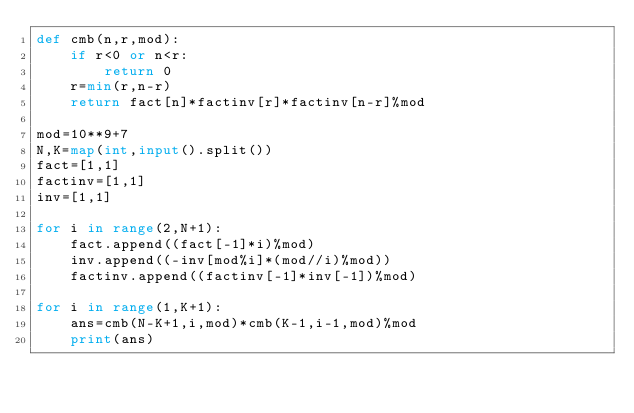Convert code to text. <code><loc_0><loc_0><loc_500><loc_500><_Python_>def cmb(n,r,mod):
    if r<0 or n<r:
        return 0
    r=min(r,n-r)
    return fact[n]*factinv[r]*factinv[n-r]%mod

mod=10**9+7
N,K=map(int,input().split())
fact=[1,1]
factinv=[1,1]
inv=[1,1]

for i in range(2,N+1):
    fact.append((fact[-1]*i)%mod)
    inv.append((-inv[mod%i]*(mod//i)%mod))
    factinv.append((factinv[-1]*inv[-1])%mod)

for i in range(1,K+1):
    ans=cmb(N-K+1,i,mod)*cmb(K-1,i-1,mod)%mod
    print(ans)</code> 